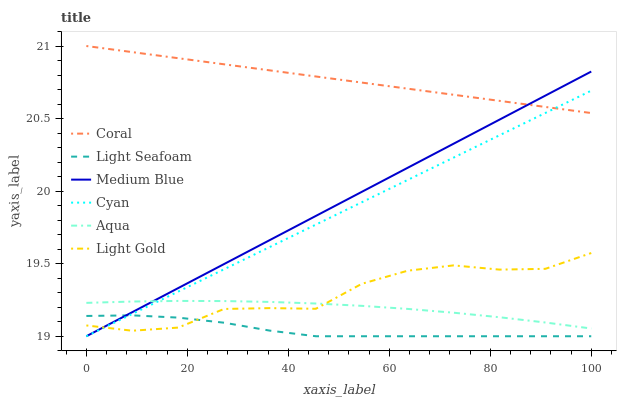Does Light Seafoam have the minimum area under the curve?
Answer yes or no. Yes. Does Aqua have the minimum area under the curve?
Answer yes or no. No. Does Aqua have the maximum area under the curve?
Answer yes or no. No. Is Light Gold the roughest?
Answer yes or no. Yes. Is Coral the smoothest?
Answer yes or no. No. Is Coral the roughest?
Answer yes or no. No. Does Aqua have the lowest value?
Answer yes or no. No. Does Aqua have the highest value?
Answer yes or no. No. Is Light Gold less than Coral?
Answer yes or no. Yes. Is Coral greater than Aqua?
Answer yes or no. Yes. Does Light Gold intersect Coral?
Answer yes or no. No. 